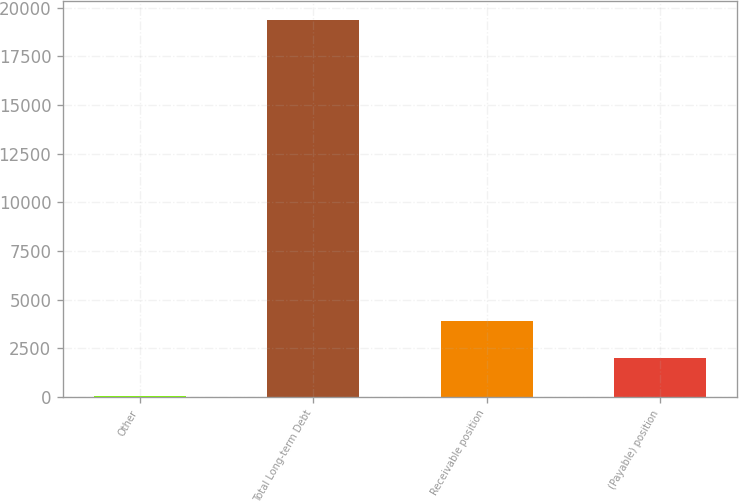Convert chart. <chart><loc_0><loc_0><loc_500><loc_500><bar_chart><fcel>Other<fcel>Total Long-term Debt<fcel>Receivable position<fcel>(Payable) position<nl><fcel>41<fcel>19366<fcel>3906<fcel>1973.5<nl></chart> 